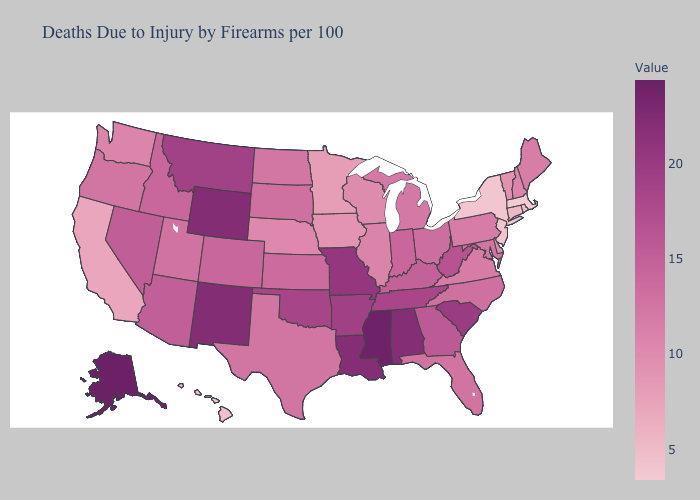Does Massachusetts have the lowest value in the USA?
Write a very short answer. Yes. Among the states that border North Dakota , does Minnesota have the lowest value?
Quick response, please. Yes. Which states have the lowest value in the MidWest?
Answer briefly. Minnesota. Does Idaho have a lower value than California?
Be succinct. No. Which states have the highest value in the USA?
Keep it brief. Alaska. Does Minnesota have the lowest value in the USA?
Be succinct. No. Does Missouri have a higher value than New Hampshire?
Answer briefly. Yes. Among the states that border North Dakota , which have the lowest value?
Give a very brief answer. Minnesota. 